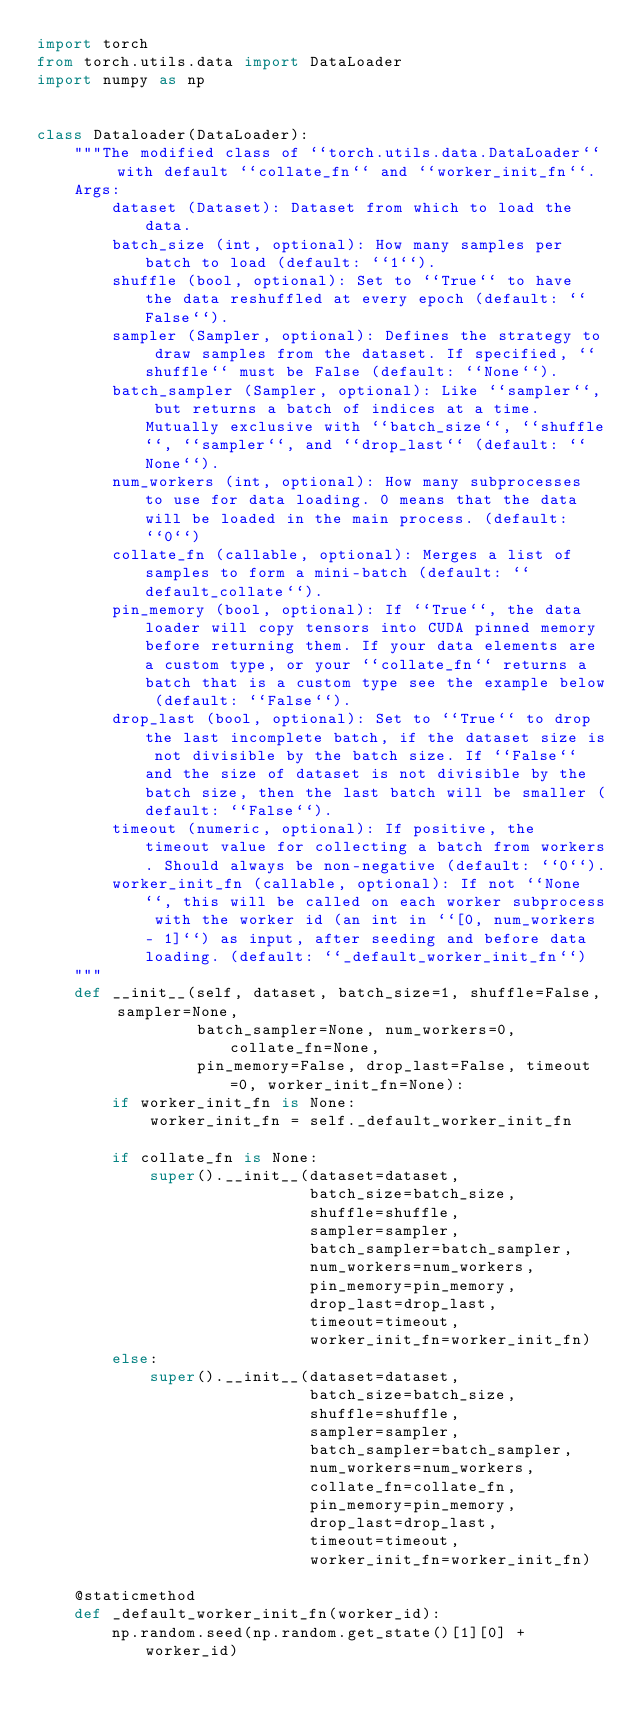Convert code to text. <code><loc_0><loc_0><loc_500><loc_500><_Python_>import torch
from torch.utils.data import DataLoader
import numpy as np


class Dataloader(DataLoader):
    """The modified class of ``torch.utils.data.DataLoader`` with default ``collate_fn`` and ``worker_init_fn``.
    Args:
        dataset (Dataset): Dataset from which to load the data.
        batch_size (int, optional): How many samples per batch to load (default: ``1``).
        shuffle (bool, optional): Set to ``True`` to have the data reshuffled at every epoch (default: ``False``).
        sampler (Sampler, optional): Defines the strategy to draw samples from the dataset. If specified, ``shuffle`` must be False (default: ``None``).
        batch_sampler (Sampler, optional): Like ``sampler``, but returns a batch of indices at a time. Mutually exclusive with ``batch_size``, ``shuffle``, ``sampler``, and ``drop_last`` (default: ``None``).
        num_workers (int, optional): How many subprocesses to use for data loading. 0 means that the data will be loaded in the main process. (default: ``0``)
        collate_fn (callable, optional): Merges a list of samples to form a mini-batch (default: ``default_collate``).
        pin_memory (bool, optional): If ``True``, the data loader will copy tensors into CUDA pinned memory before returning them. If your data elements are a custom type, or your ``collate_fn`` returns a batch that is a custom type see the example below (default: ``False``).
        drop_last (bool, optional): Set to ``True`` to drop the last incomplete batch, if the dataset size is not divisible by the batch size. If ``False`` and the size of dataset is not divisible by the batch size, then the last batch will be smaller (default: ``False``).
        timeout (numeric, optional): If positive, the timeout value for collecting a batch from workers. Should always be non-negative (default: ``0``).
        worker_init_fn (callable, optional): If not ``None``, this will be called on each worker subprocess with the worker id (an int in ``[0, num_workers - 1]``) as input, after seeding and before data loading. (default: ``_default_worker_init_fn``)
    """
    def __init__(self, dataset, batch_size=1, shuffle=False, sampler=None,
                 batch_sampler=None, num_workers=0, collate_fn=None,
                 pin_memory=False, drop_last=False, timeout=0, worker_init_fn=None):
        if worker_init_fn is None:
            worker_init_fn = self._default_worker_init_fn

        if collate_fn is None:
            super().__init__(dataset=dataset,
                             batch_size=batch_size,
                             shuffle=shuffle,
                             sampler=sampler,
                             batch_sampler=batch_sampler,
                             num_workers=num_workers,
                             pin_memory=pin_memory,
                             drop_last=drop_last,
                             timeout=timeout,
                             worker_init_fn=worker_init_fn)
        else:
            super().__init__(dataset=dataset,
                             batch_size=batch_size,
                             shuffle=shuffle,
                             sampler=sampler,
                             batch_sampler=batch_sampler,
                             num_workers=num_workers,
                             collate_fn=collate_fn,
                             pin_memory=pin_memory,
                             drop_last=drop_last,
                             timeout=timeout,
                             worker_init_fn=worker_init_fn)

    @staticmethod
    def _default_worker_init_fn(worker_id):
        np.random.seed(np.random.get_state()[1][0] + worker_id)
</code> 